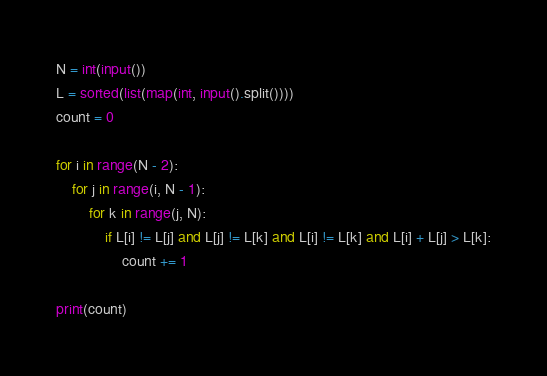Convert code to text. <code><loc_0><loc_0><loc_500><loc_500><_Python_>N = int(input())
L = sorted(list(map(int, input().split())))
count = 0

for i in range(N - 2):
    for j in range(i, N - 1):
        for k in range(j, N):
            if L[i] != L[j] and L[j] != L[k] and L[i] != L[k] and L[i] + L[j] > L[k]:
                count += 1

print(count)</code> 